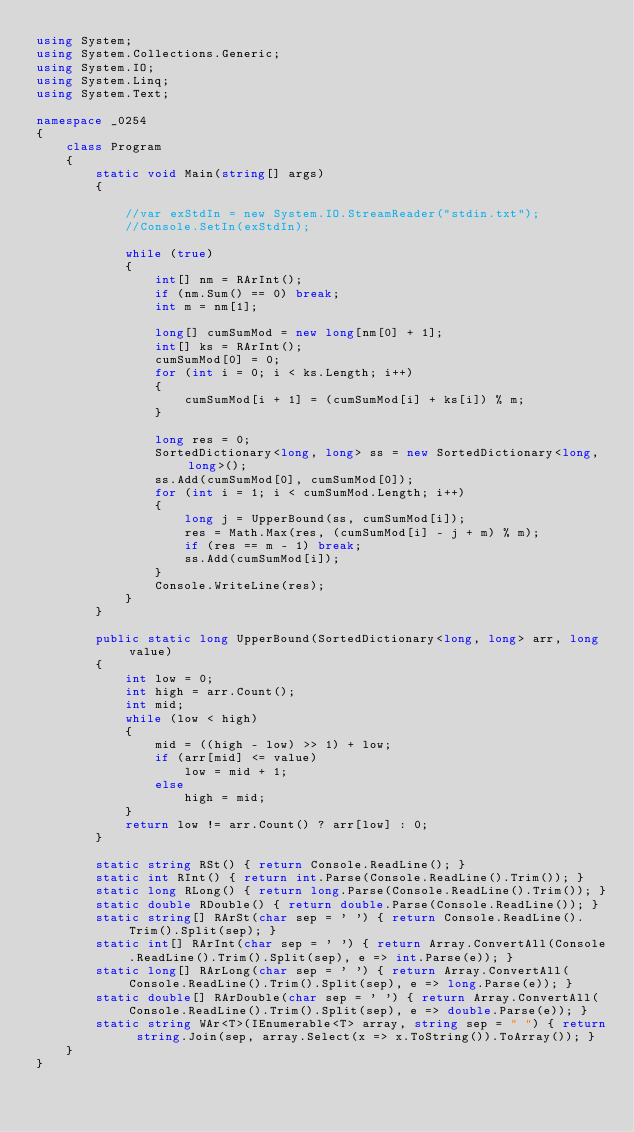Convert code to text. <code><loc_0><loc_0><loc_500><loc_500><_C#_>using System;
using System.Collections.Generic;
using System.IO;
using System.Linq;
using System.Text;

namespace _0254
{
    class Program
    {
        static void Main(string[] args)
        {

            //var exStdIn = new System.IO.StreamReader("stdin.txt");
            //Console.SetIn(exStdIn);

            while (true)
            {
                int[] nm = RArInt();
                if (nm.Sum() == 0) break;
                int m = nm[1];

                long[] cumSumMod = new long[nm[0] + 1];
                int[] ks = RArInt();
                cumSumMod[0] = 0;
                for (int i = 0; i < ks.Length; i++)
                {
                    cumSumMod[i + 1] = (cumSumMod[i] + ks[i]) % m;
                }

                long res = 0;
                SortedDictionary<long, long> ss = new SortedDictionary<long, long>();
                ss.Add(cumSumMod[0], cumSumMod[0]);
                for (int i = 1; i < cumSumMod.Length; i++)
                {
                    long j = UpperBound(ss, cumSumMod[i]);
                    res = Math.Max(res, (cumSumMod[i] - j + m) % m);
                    if (res == m - 1) break;
                    ss.Add(cumSumMod[i]);
                }
                Console.WriteLine(res);
            }
        }

        public static long UpperBound(SortedDictionary<long, long> arr, long value)
        {
            int low = 0;
            int high = arr.Count();
            int mid;
            while (low < high)
            {
                mid = ((high - low) >> 1) + low;
                if (arr[mid] <= value)
                    low = mid + 1;
                else
                    high = mid;
            }
            return low != arr.Count() ? arr[low] : 0;
        }

        static string RSt() { return Console.ReadLine(); }
        static int RInt() { return int.Parse(Console.ReadLine().Trim()); }
        static long RLong() { return long.Parse(Console.ReadLine().Trim()); }
        static double RDouble() { return double.Parse(Console.ReadLine()); }
        static string[] RArSt(char sep = ' ') { return Console.ReadLine().Trim().Split(sep); }
        static int[] RArInt(char sep = ' ') { return Array.ConvertAll(Console.ReadLine().Trim().Split(sep), e => int.Parse(e)); }
        static long[] RArLong(char sep = ' ') { return Array.ConvertAll(Console.ReadLine().Trim().Split(sep), e => long.Parse(e)); }
        static double[] RArDouble(char sep = ' ') { return Array.ConvertAll(Console.ReadLine().Trim().Split(sep), e => double.Parse(e)); }
        static string WAr<T>(IEnumerable<T> array, string sep = " ") { return string.Join(sep, array.Select(x => x.ToString()).ToArray()); }
    }
}

</code> 